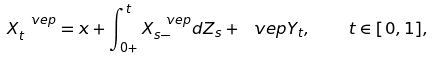<formula> <loc_0><loc_0><loc_500><loc_500>X ^ { \ v e p } _ { t } = x + \int _ { 0 + } ^ { t } X ^ { \ v e p } _ { s - } d Z _ { s } + \ v e p Y _ { t } , \quad t \in [ 0 , 1 ] ,</formula> 